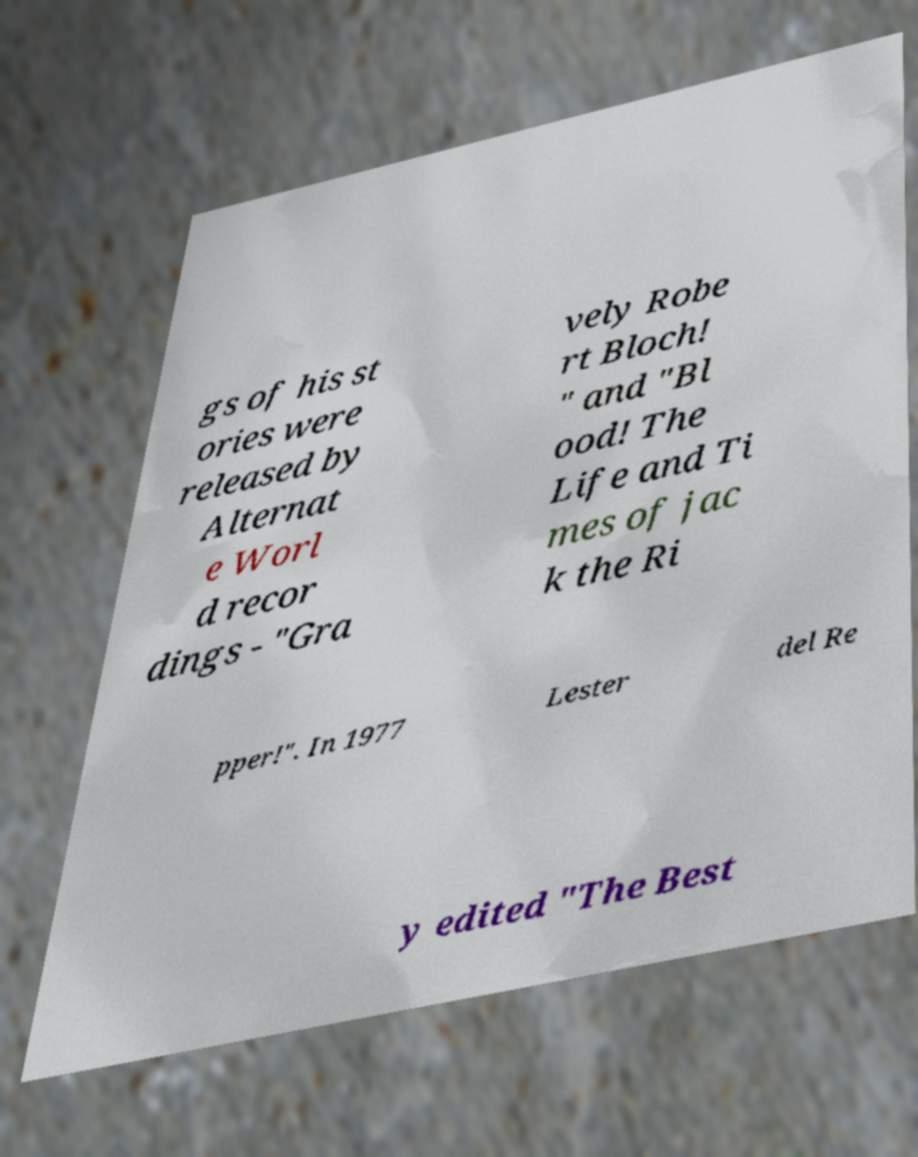Could you extract and type out the text from this image? gs of his st ories were released by Alternat e Worl d recor dings - "Gra vely Robe rt Bloch! " and "Bl ood! The Life and Ti mes of jac k the Ri pper!". In 1977 Lester del Re y edited "The Best 